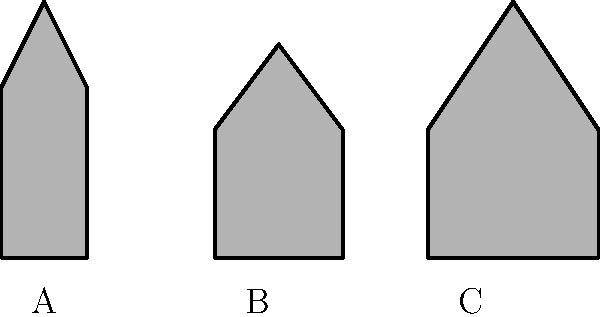Which silhouette represents the architectural style commonly associated with the Independence Hall in Philadelphia? To answer this question, let's analyze each silhouette and its corresponding architectural style:

1. Silhouette A: This shape features a symmetrical design with a central triangular pediment and a relatively steep roof. These are characteristics of Colonial architecture, which was prevalent in early American history.

2. Silhouette B: This shape shows a low-pitched roof with a prominent triangular pediment, resembling a classical temple front. These are key features of Greek Revival architecture.

3. Silhouette C: This silhouette displays a steeply pitched roof with a central point, suggestive of Gothic Revival architecture with its emphasis on vertical lines and pointed arches.

Independence Hall, completed in 1753, is a prime example of Georgian architecture, which is a subset of Colonial architecture. It features symmetrical design, a central section with a triangular pediment, and a bell tower – elements that align most closely with Silhouette A.

Therefore, the silhouette that best represents the architectural style of Independence Hall is Silhouette A, which depicts Colonial architecture.
Answer: A 